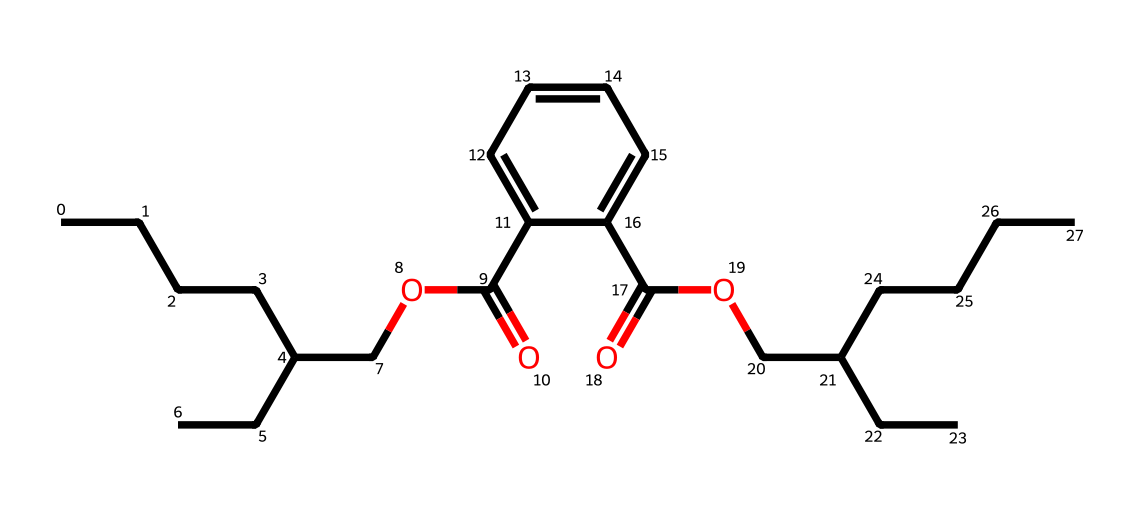How many carbon atoms are in the chemical structure? Analyzing the SMILES representation, we can count the occurrence of the letter "C". Each "C" represents a carbon atom, and after counting, there are 21 carbon atoms in total.
Answer: 21 What is the main functional group present in this chemical? The presence of "COC(=O)" in the SMILES shows that there is an ester functional group due to the carbonyl (C=O) adjacent to an ether (C-O). Thus, the primary functional group present is an ester.
Answer: ester What is the total number of oxygen atoms in this structure? By scanning through the SMILES, we can identify instances of "O." There are 4 occurrences of oxygen atoms in total, confirming that there are 4 oxygen atoms in the structure.
Answer: 4 Which part of the chemical structure is likely responsible for its plasticizing properties? The long carbon chains and ester groups contribute to the flexibility and compatibility with polymers, which make phthalates effective plasticizers; thus, the ester functional groups in conjunction with the long alkyl chains are responsible for plasticizing.
Answer: ester groups What type of chemical substance is this compound primarily classified as? Given that phthalates are often used as plasticizers, and considering the structure reveals a long-chain compound with ester functionalities, it primarily classifies as a phthalate ester.
Answer: phthalate ester What is the significance of the aromatic ring present in this structure? The presence of the aromatic ring (denoted by "c1ccccc1") usually contributes to stability and rigidity to the molecule, which can affect the overall properties such as thermal stability and mechanical strength, important for applications in plastics.
Answer: stability 